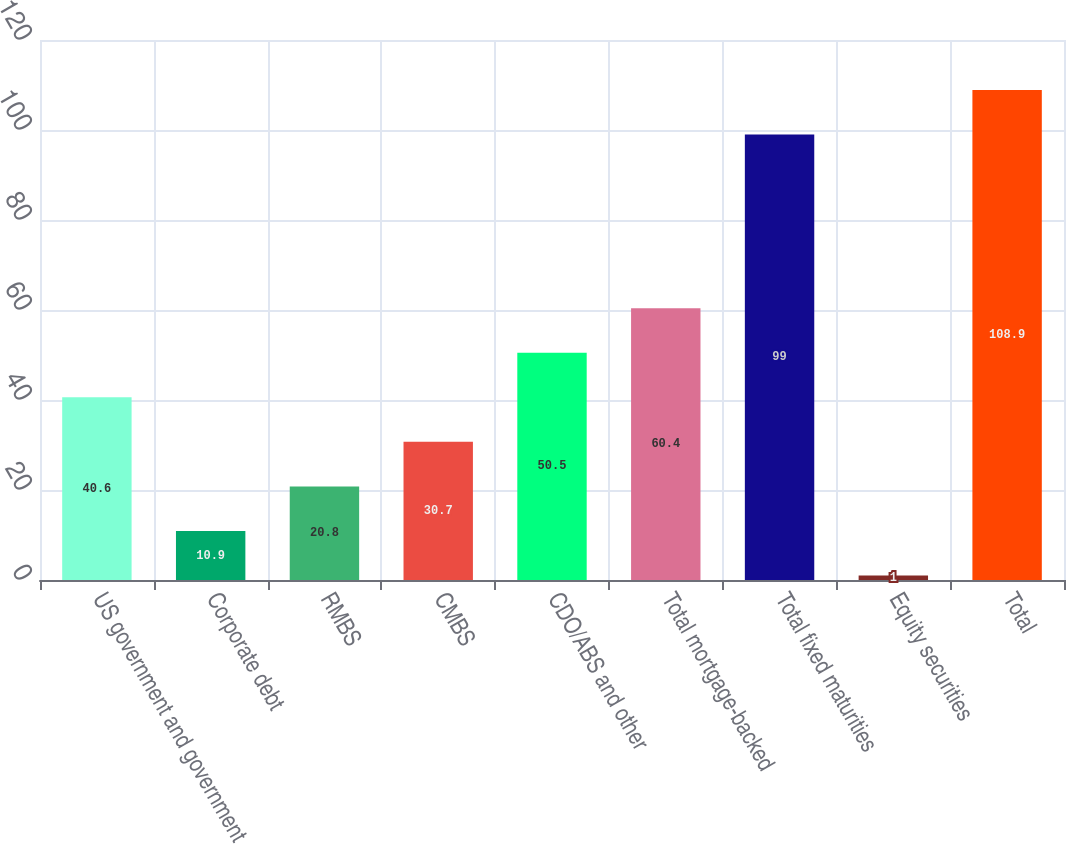Convert chart. <chart><loc_0><loc_0><loc_500><loc_500><bar_chart><fcel>US government and government<fcel>Corporate debt<fcel>RMBS<fcel>CMBS<fcel>CDO/ABS and other<fcel>Total mortgage-backed<fcel>Total fixed maturities<fcel>Equity securities<fcel>Total<nl><fcel>40.6<fcel>10.9<fcel>20.8<fcel>30.7<fcel>50.5<fcel>60.4<fcel>99<fcel>1<fcel>108.9<nl></chart> 